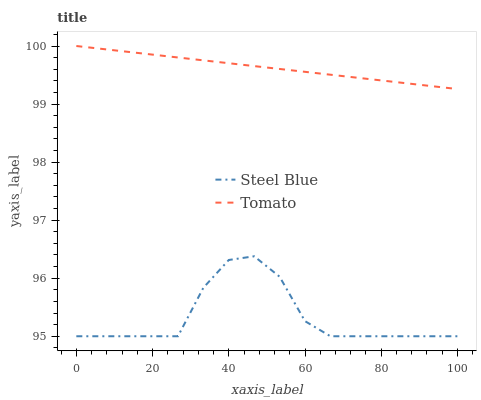Does Steel Blue have the minimum area under the curve?
Answer yes or no. Yes. Does Tomato have the maximum area under the curve?
Answer yes or no. Yes. Does Steel Blue have the maximum area under the curve?
Answer yes or no. No. Is Tomato the smoothest?
Answer yes or no. Yes. Is Steel Blue the roughest?
Answer yes or no. Yes. Is Steel Blue the smoothest?
Answer yes or no. No. Does Tomato have the highest value?
Answer yes or no. Yes. Does Steel Blue have the highest value?
Answer yes or no. No. Is Steel Blue less than Tomato?
Answer yes or no. Yes. Is Tomato greater than Steel Blue?
Answer yes or no. Yes. Does Steel Blue intersect Tomato?
Answer yes or no. No. 